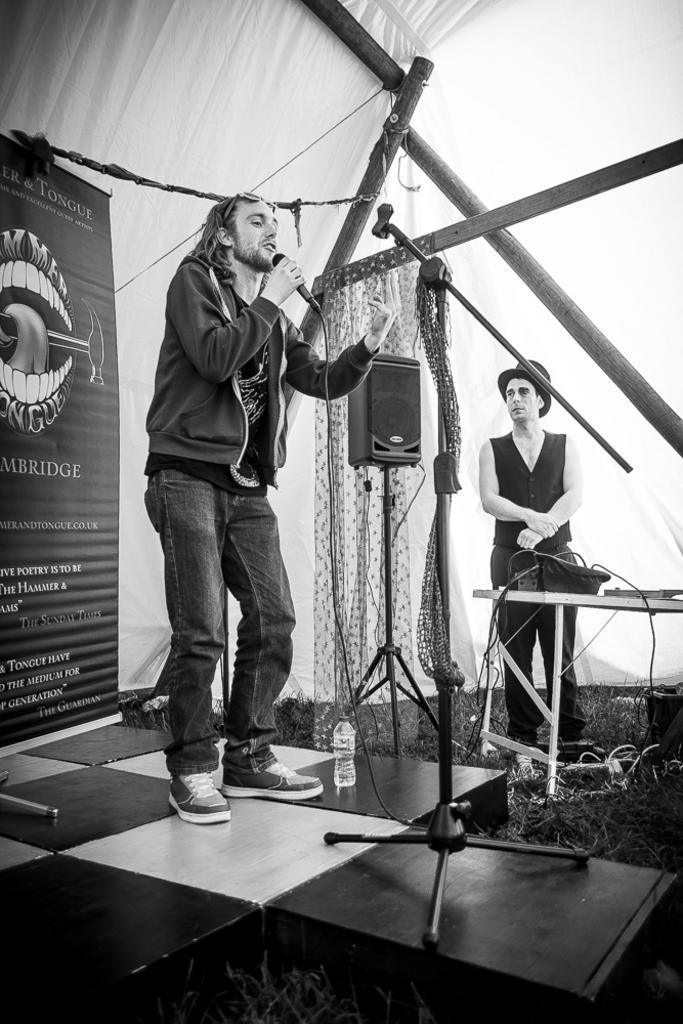In one or two sentences, can you explain what this image depicts? This picture is a black and white image. In this image we can see one stage, one white curtain, some rods, one table, some objects on the table, one microphone stand on the stage, one object on the stage, one speaker with stand, one water bottle, two men standing, some objects on the ground, some grass on the ground, one banner with text and image on the left side of the image. One man holding a microphone and talking on the stage. 